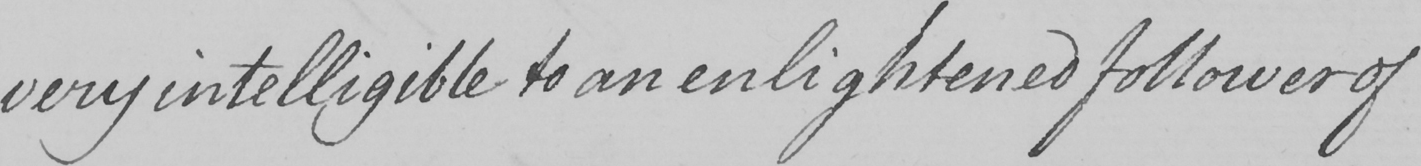What is written in this line of handwriting? very intelligible to an enlightened follower of 